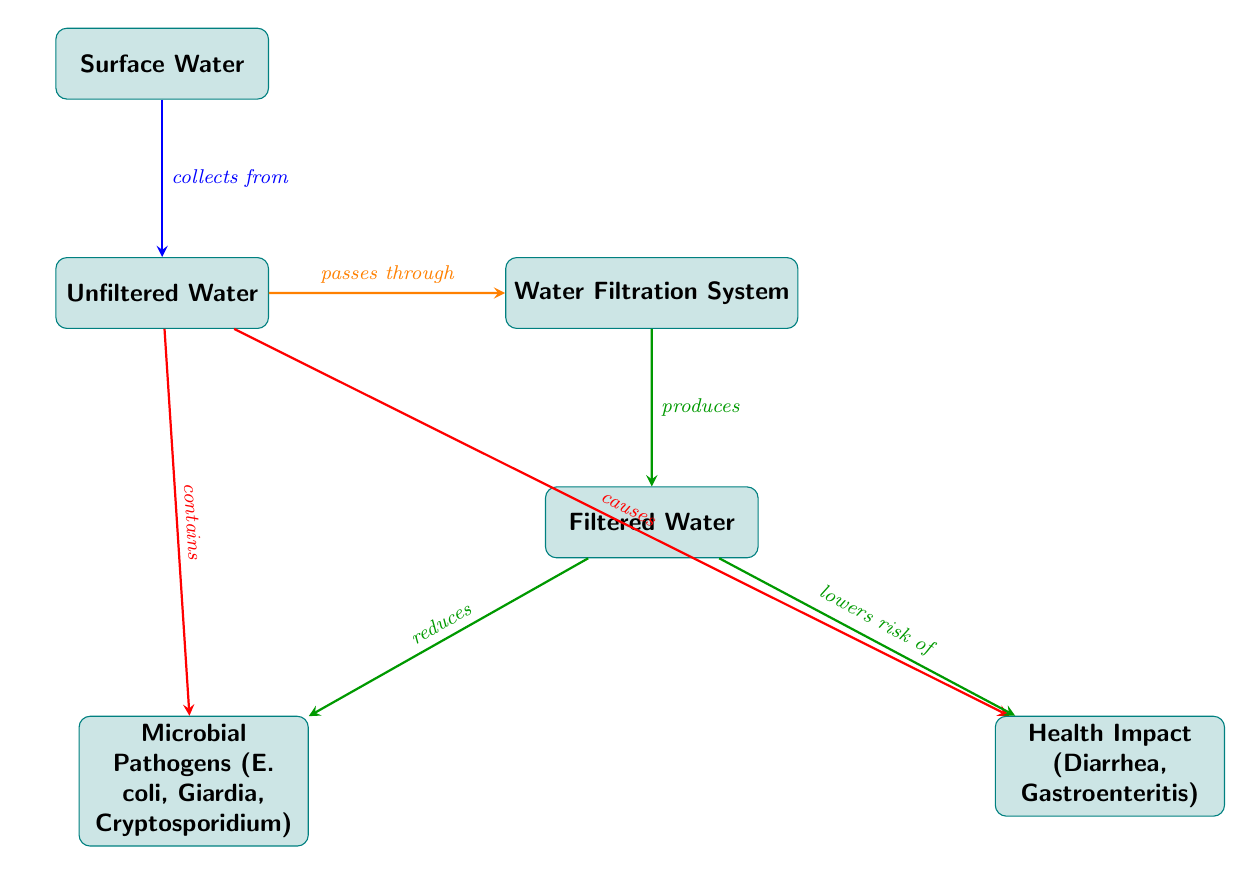What is the first node in the diagram? The first node is labeled "Surface Water," which is the starting point of the food chain as indicated by its position at the top of the diagram.
Answer: Surface Water What does Unfiltered Water contain? The Unfiltered Water node points to two arrows that indicate it "contains" microbial pathogens, specifically E. coli, Giardia, and Cryptosporidium.
Answer: Microbial Pathogens (E. coli, Giardia, Cryptosporidium) What is produced after the Water Filtration System? The arrow from the Water Filtration System leads directly to the Filtered Water node, indicating that the filtration system produces filtered water as its output.
Answer: Filtered Water What health impact is associated with Unfiltered Water? Unfiltered Water is associated with a health impact identified as "Diarrhea, Gastroenteritis," which is shown being caused by the Unfiltered Water node.
Answer: Diarrhea, Gastroenteritis What relationship exists between Filtered Water and microbial pathogens? According to the arrows leading from the Filtered Water node, it is noted that Filtered Water "reduces" the levels of microbial pathogens, indicating a beneficial relationship.
Answer: Reduces How many total nodes are there in the diagram? The diagram depicts a total of six nodes: Surface Water, Unfiltered Water, Water Filtration System, Filtered Water, Microbial Pathogens, and Health Impact. By counting them, we can verify there are indeed six distinct nodes represented in the diagram.
Answer: Six What does Filtered Water lower the risk of? The arrow from the Filtered Water node indicates it "lowers risk of" health impacts, specifically identified as Diarrhea and Gastroenteritis in the diagram.
Answer: Lowers risk of What happens to Unfiltered Water as it passes through the filtration system? The arrow indicating the passing through the filtration system shows that the Unfiltered Water is processed into Filtered Water, demonstrating a transformation due to the filtration process.
Answer: Produces What type of water is processed through the Water Filtration System? The Water Filtration System is described to process "Unfiltered Water," as shown by the arrow pointing into the process from the Unfiltered Water node.
Answer: Unfiltered Water 